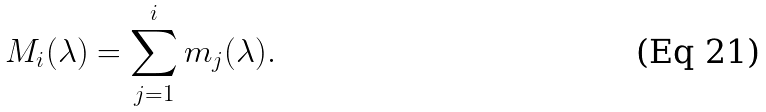<formula> <loc_0><loc_0><loc_500><loc_500>M _ { i } ( \lambda ) = \sum _ { j = 1 } ^ { i } m _ { j } ( \lambda ) .</formula> 